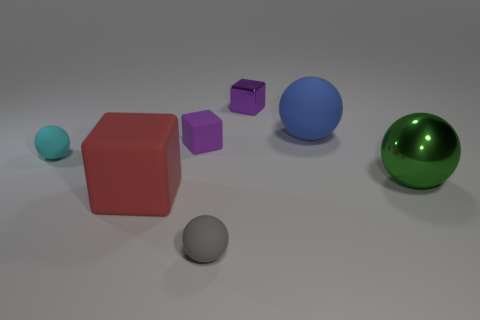Subtract all purple spheres. Subtract all red blocks. How many spheres are left? 4 Add 1 small shiny blocks. How many objects exist? 8 Subtract all blocks. How many objects are left? 4 Add 7 tiny purple things. How many tiny purple things exist? 9 Subtract 0 yellow cubes. How many objects are left? 7 Subtract all small purple shiny things. Subtract all gray rubber spheres. How many objects are left? 5 Add 6 cyan spheres. How many cyan spheres are left? 7 